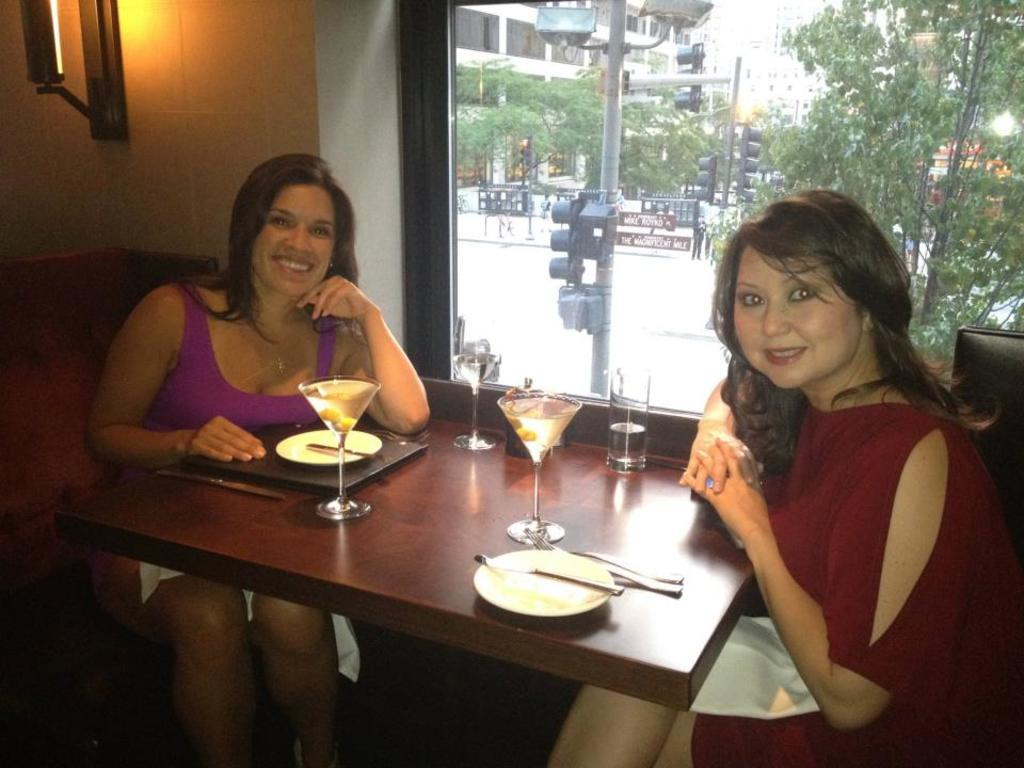How many women are in the image? There are two women in the image. What are the women doing in the image? The women are sitting on chairs. Where are the chairs located in relation to the table? The chairs are in front of the table. What can be found on the table in the image? There are glasses, plates, and other objects on the table. What type of wren can be seen singing on the table in the image? There is no wren present in the image; it features two women sitting in front of a table with glasses, plates, and other objects. 